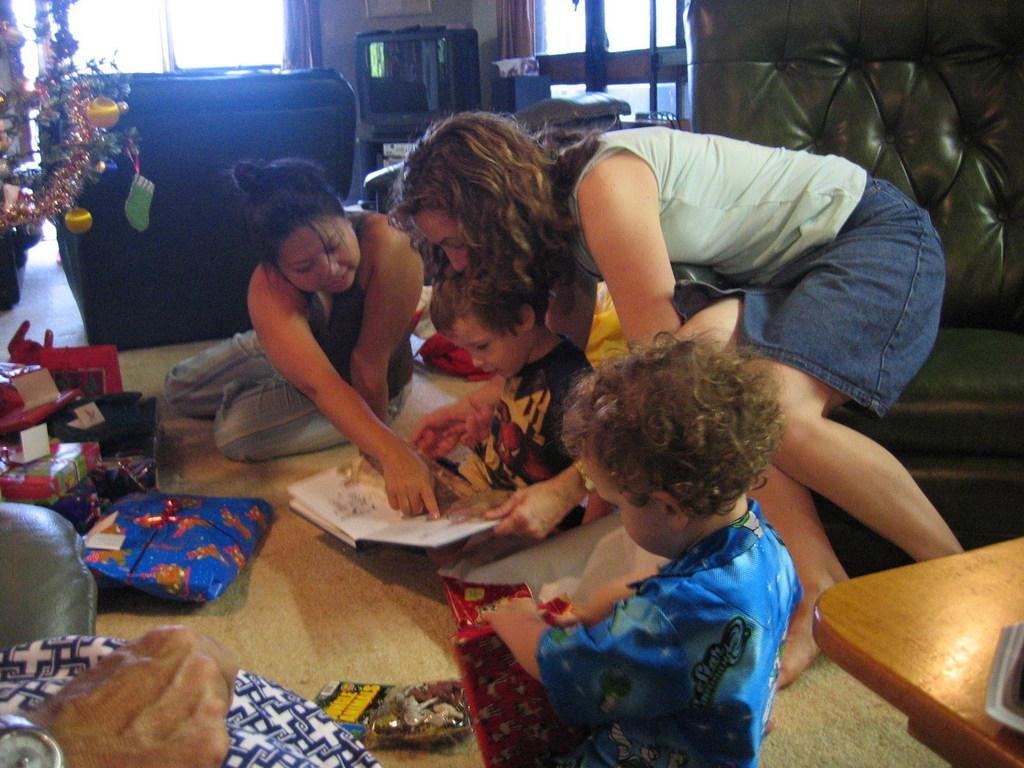Can you describe this image briefly? This is a picture of group of people sitting in the floor and in back ground there is couch , table , television , christmas tree and some gifts. 